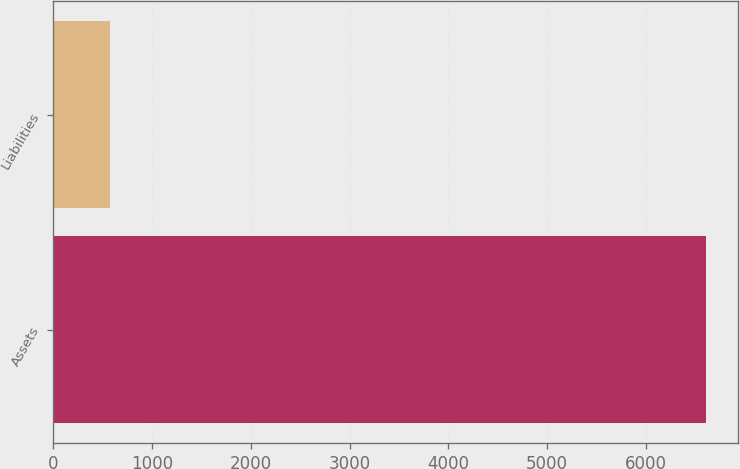Convert chart. <chart><loc_0><loc_0><loc_500><loc_500><bar_chart><fcel>Assets<fcel>Liabilities<nl><fcel>6605<fcel>576<nl></chart> 